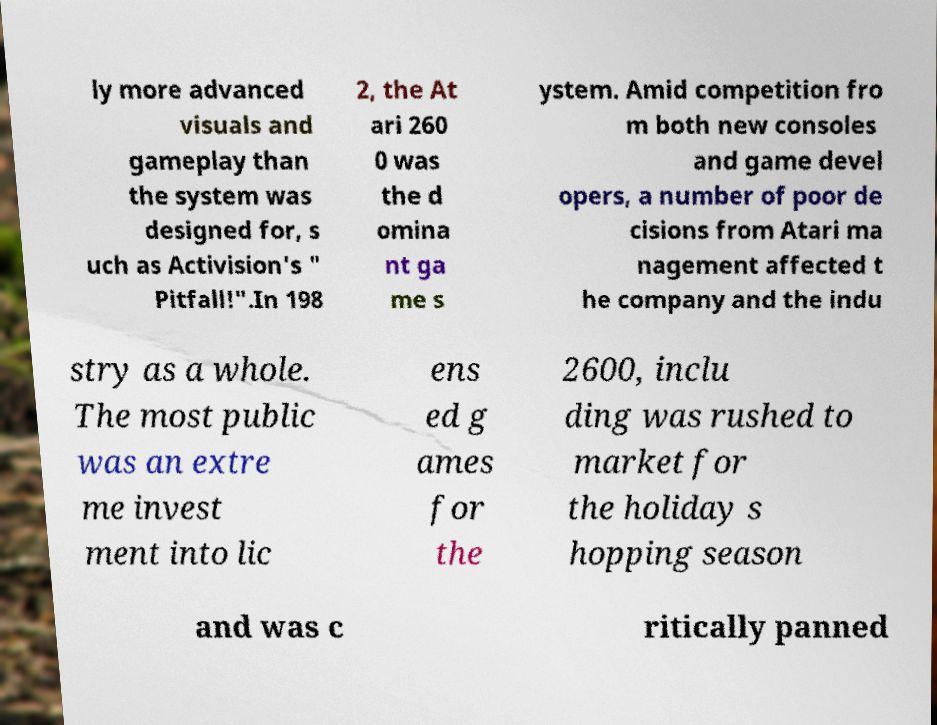Please identify and transcribe the text found in this image. ly more advanced visuals and gameplay than the system was designed for, s uch as Activision's " Pitfall!".In 198 2, the At ari 260 0 was the d omina nt ga me s ystem. Amid competition fro m both new consoles and game devel opers, a number of poor de cisions from Atari ma nagement affected t he company and the indu stry as a whole. The most public was an extre me invest ment into lic ens ed g ames for the 2600, inclu ding was rushed to market for the holiday s hopping season and was c ritically panned 